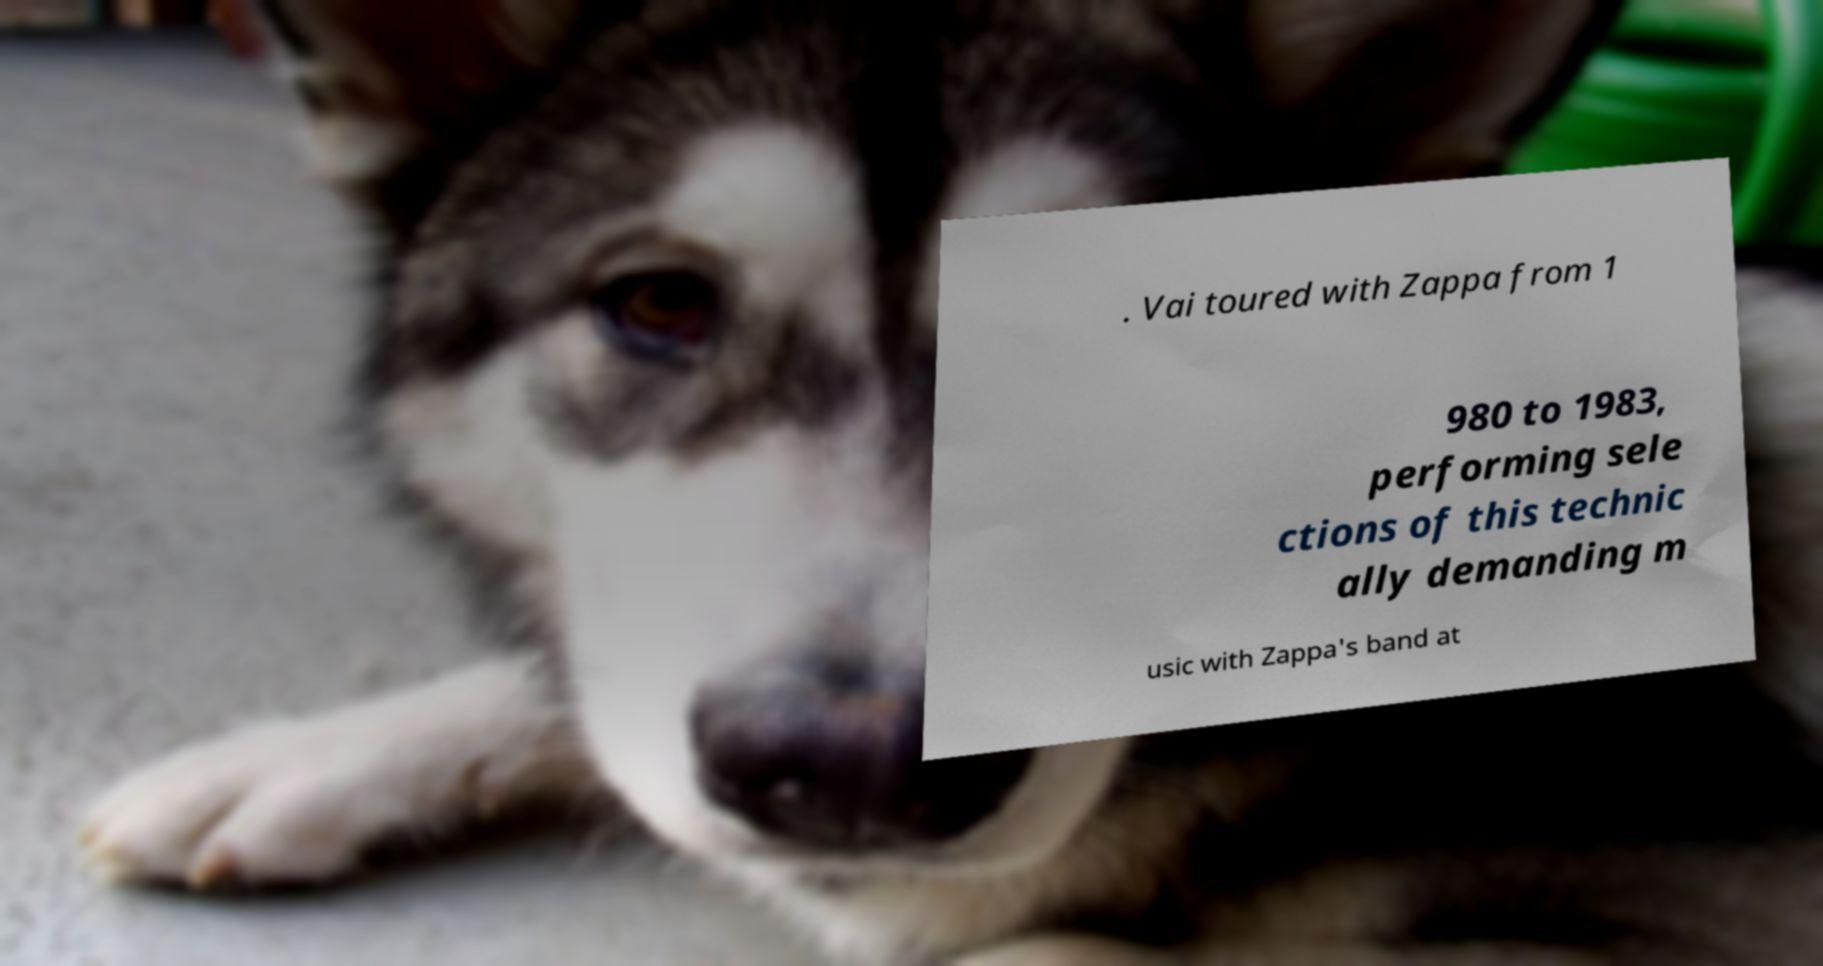Can you accurately transcribe the text from the provided image for me? . Vai toured with Zappa from 1 980 to 1983, performing sele ctions of this technic ally demanding m usic with Zappa's band at 